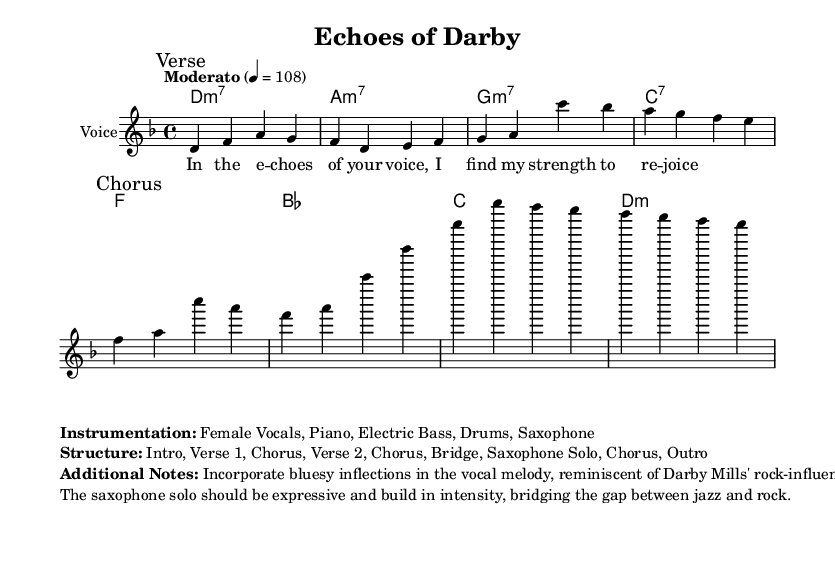What is the key signature of this music? The key signature is D minor, indicated by the presence of one flat (B flat), which aligns with the overall tonality of the piece.
Answer: D minor What is the time signature of the piece? The time signature is indicated at the beginning with the '4/4' symbol, meaning there are four beats in each measure and the quarter note gets one beat.
Answer: 4/4 What is the tempo marking for this piece? The tempo marking is "Moderato" with a metronome marking of 108, suggesting a moderate speed for the performance.
Answer: Moderato How many sections are in the structure of the piece? The structure is detailed as Intro, Verse 1, Chorus, Verse 2, Chorus, Bridge, Saxophone Solo, Chorus, Outro, which totals to 9 sections in the arrangement.
Answer: 9 sections What instrument plays the melody in this score? The melody is written for the voice, as indicated by the staff labeled "Voice" in the sheet music.
Answer: Voice Which musical elements are incorporated in the vocal melody? The additional notes mention incorporating bluesy inflections in the vocal melody, which reflects characteristics often found in rock-influenced styles.
Answer: Bluesy inflections What style influences the saxophone solo? The notes state that the saxophone solo should be expressive and build in intensity, indicating an influence that merges jazz and rock styles.
Answer: Jazz and rock 